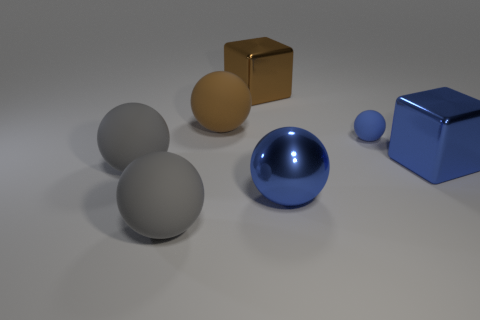What is the material of the other large object that is the same shape as the large brown shiny object?
Offer a terse response. Metal. What is the material of the large blue thing that is to the right of the big blue metallic object in front of the shiny cube to the right of the small rubber sphere?
Your response must be concise. Metal. There is a small blue thing; does it have the same shape as the blue object that is in front of the blue metal cube?
Your response must be concise. Yes. How many big gray matte things have the same shape as the brown metal thing?
Keep it short and to the point. 0. What is the shape of the large brown metallic thing?
Your answer should be compact. Cube. What size is the cube that is behind the cube that is in front of the big brown metal thing?
Offer a very short reply. Large. How many objects are either large brown rubber balls or brown shiny objects?
Ensure brevity in your answer.  2. Does the brown rubber object have the same shape as the blue matte object?
Your answer should be compact. Yes. Are there any brown objects that have the same material as the large blue sphere?
Provide a succinct answer. Yes. There is a brown thing in front of the brown metallic object; is there a brown metallic thing in front of it?
Give a very brief answer. No. 